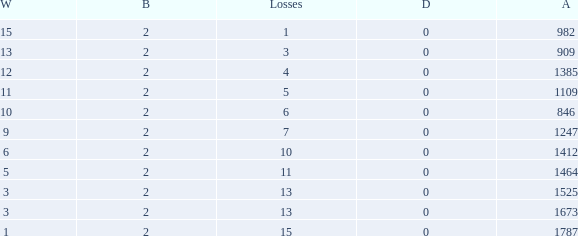What is the highest number listed under against when there were 15 losses and more than 1 win? None. 